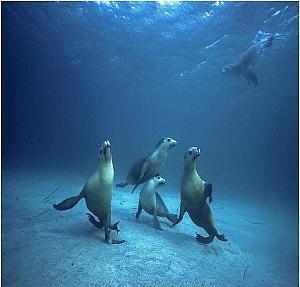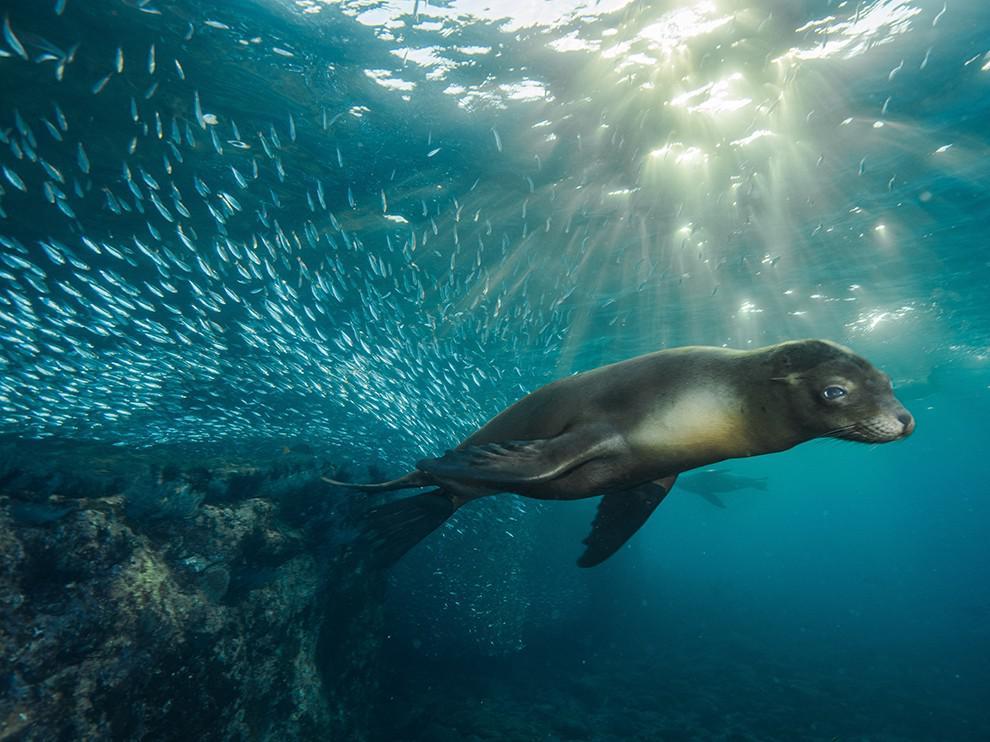The first image is the image on the left, the second image is the image on the right. Given the left and right images, does the statement "The left image contains no more than one seal." hold true? Answer yes or no. No. The first image is the image on the left, the second image is the image on the right. Assess this claim about the two images: "An image shows a seal with its nose close to the camera, and no image contains more than one seal in the foreground.". Correct or not? Answer yes or no. No. 